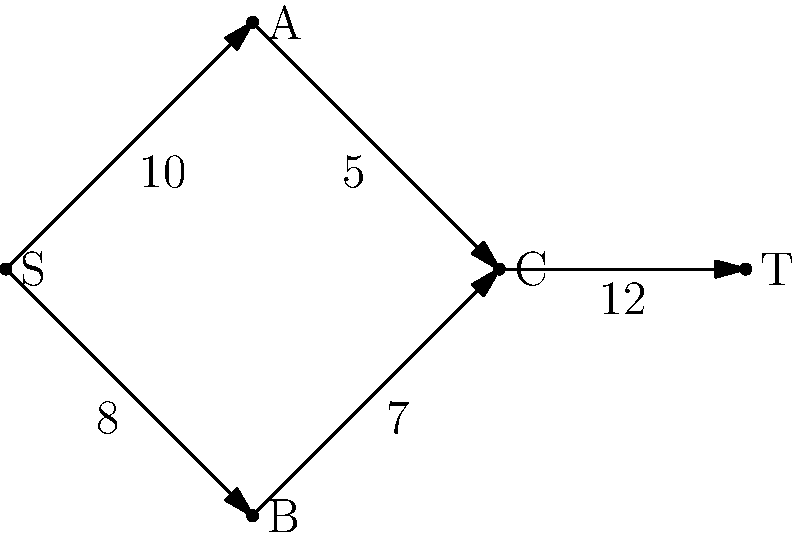As a data analyst in a supply chain logistics company, you're tasked with optimizing the flow of goods through a network represented by the directed graph above. The numbers on each edge represent the maximum capacity of goods that can flow through that path. What is the maximum flow that can be achieved from source S to sink T? To solve this maximum flow problem, we'll use the Ford-Fulkerson algorithm:

1. Initialize flow to 0 for all edges.

2. Find an augmenting path from S to T:
   Path 1: S → A → C → T (min capacity: 5)
   Increase flow by 5.
   Current max flow: 5

3. Find another augmenting path:
   Path 2: S → B → C → T (min capacity: 7)
   Increase flow by 7.
   Current max flow: 5 + 7 = 12

4. Find another augmenting path:
   Path 3: S → A → C → T (residual capacity: 10 - 5 = 5, 12 - 12 = 0)
   This path is blocked at C → T.

5. No more augmenting paths exist.

The maximum flow is the sum of all flow increases: 5 + 7 = 12.

This can be verified by checking the total outflow from S (10 + 2 = 12) or the total inflow to T (12).
Answer: 12 units 